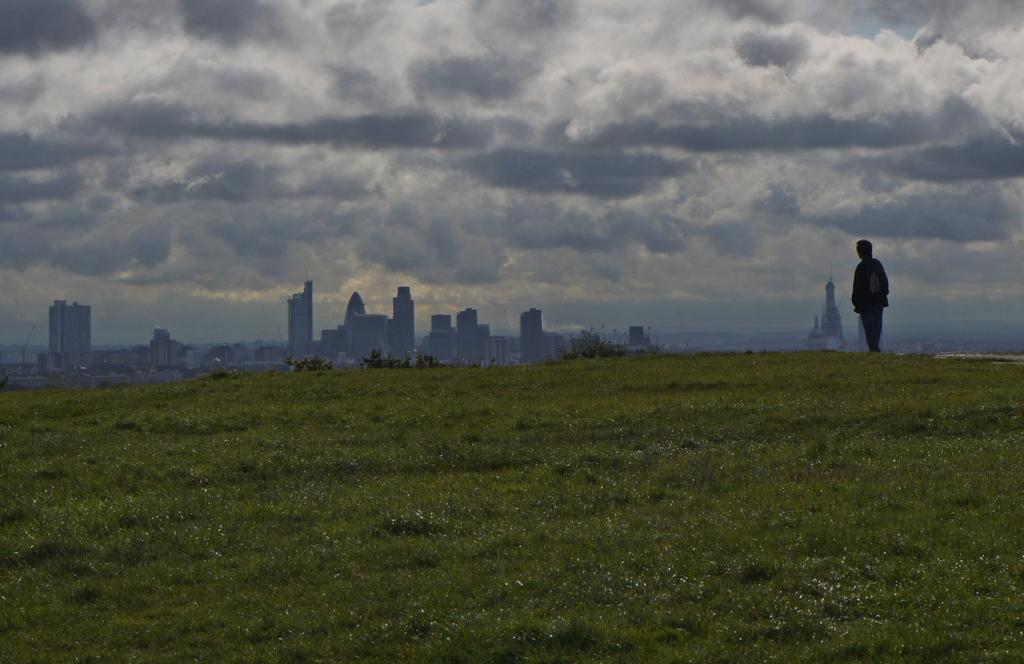What type of surface is visible in the image? There is grass on the surface in the image. Where is the person located in the image? The person is on the right side of the image. What can be seen in the distance in the image? There are buildings in the background of the image. What is visible above the buildings in the image? The sky is visible in the background of the image. What type of produce is being stamped on the grass in the image? There is no produce or stamping activity present in the image. 